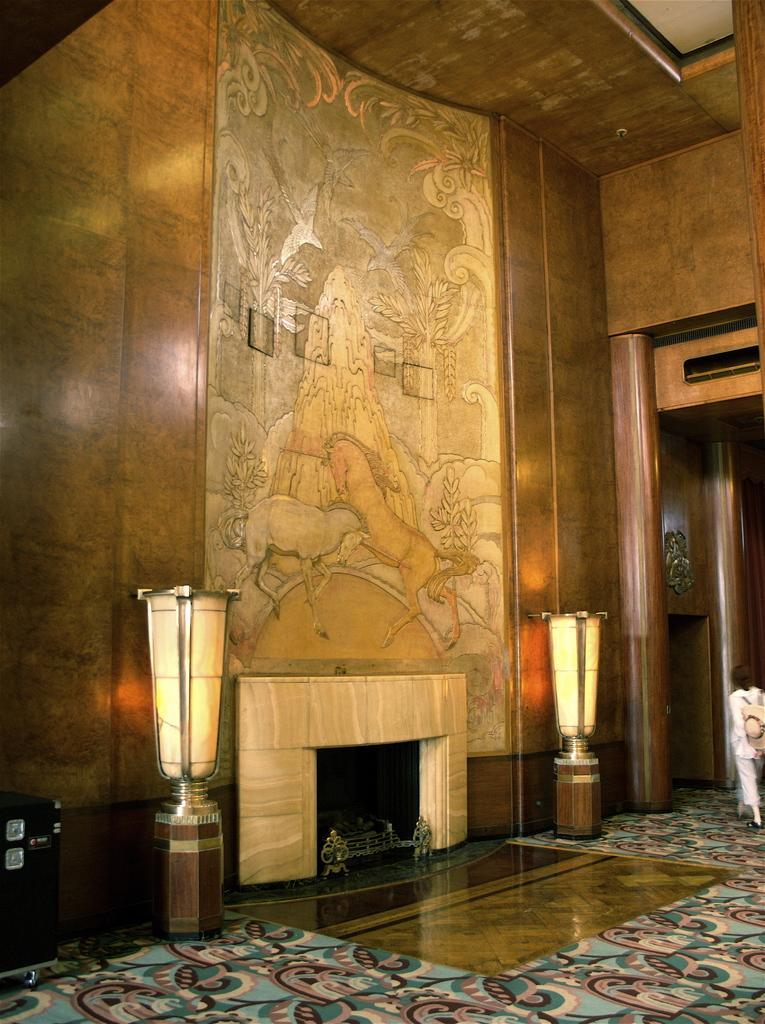How would you summarize this image in a sentence or two? In this image we can see a wall with some design on it. And we can see the hearth. 